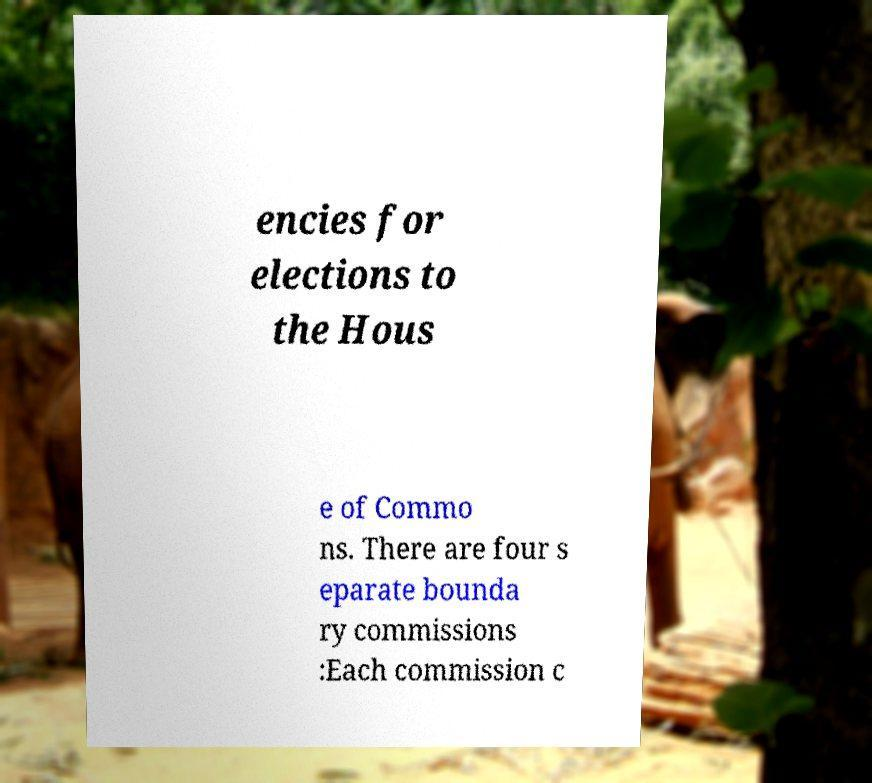Can you accurately transcribe the text from the provided image for me? encies for elections to the Hous e of Commo ns. There are four s eparate bounda ry commissions :Each commission c 